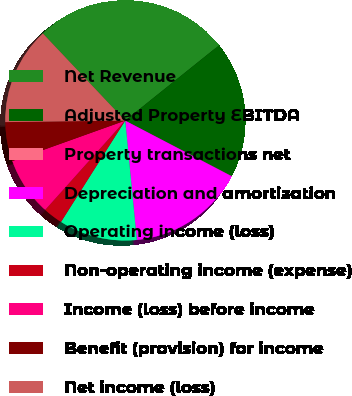<chart> <loc_0><loc_0><loc_500><loc_500><pie_chart><fcel>Net Revenue<fcel>Adjusted Property EBITDA<fcel>Property transactions net<fcel>Depreciation and amortization<fcel>Operating income (loss)<fcel>Non-operating income (expense)<fcel>Income (loss) before income<fcel>Benefit (provision) for income<fcel>Net income (loss)<nl><fcel>26.29%<fcel>18.41%<fcel>0.02%<fcel>15.78%<fcel>10.53%<fcel>2.64%<fcel>7.9%<fcel>5.27%<fcel>13.15%<nl></chart> 